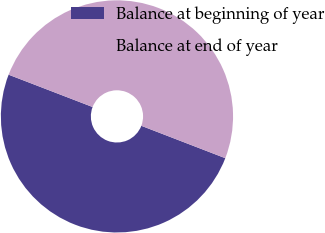Convert chart. <chart><loc_0><loc_0><loc_500><loc_500><pie_chart><fcel>Balance at beginning of year<fcel>Balance at end of year<nl><fcel>49.99%<fcel>50.01%<nl></chart> 